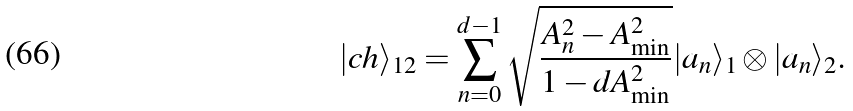Convert formula to latex. <formula><loc_0><loc_0><loc_500><loc_500>| c h \rangle _ { 1 2 } = \sum _ { n = 0 } ^ { d - 1 } \sqrt { \frac { A _ { n } ^ { 2 } - A _ { \min } ^ { 2 } } { 1 - d A _ { \min } ^ { 2 } } } | a _ { n } \rangle _ { 1 } \otimes | a _ { n } \rangle _ { 2 } .</formula> 